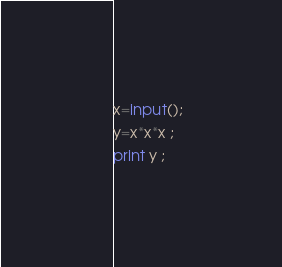Convert code to text. <code><loc_0><loc_0><loc_500><loc_500><_Python_>x=input();
y=x*x*x ;
print y ;</code> 